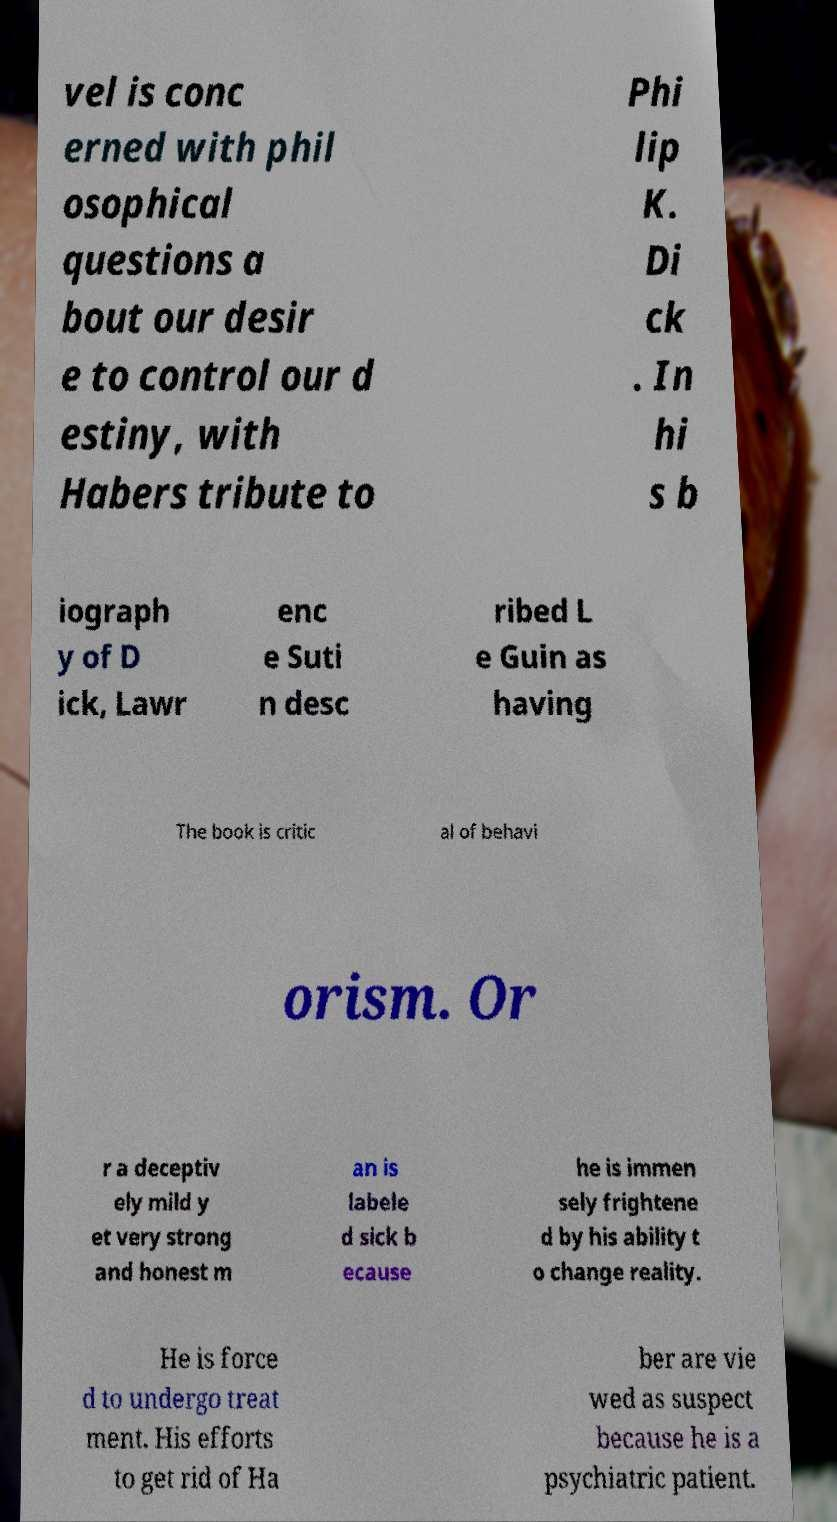Please identify and transcribe the text found in this image. vel is conc erned with phil osophical questions a bout our desir e to control our d estiny, with Habers tribute to Phi lip K. Di ck . In hi s b iograph y of D ick, Lawr enc e Suti n desc ribed L e Guin as having The book is critic al of behavi orism. Or r a deceptiv ely mild y et very strong and honest m an is labele d sick b ecause he is immen sely frightene d by his ability t o change reality. He is force d to undergo treat ment. His efforts to get rid of Ha ber are vie wed as suspect because he is a psychiatric patient. 